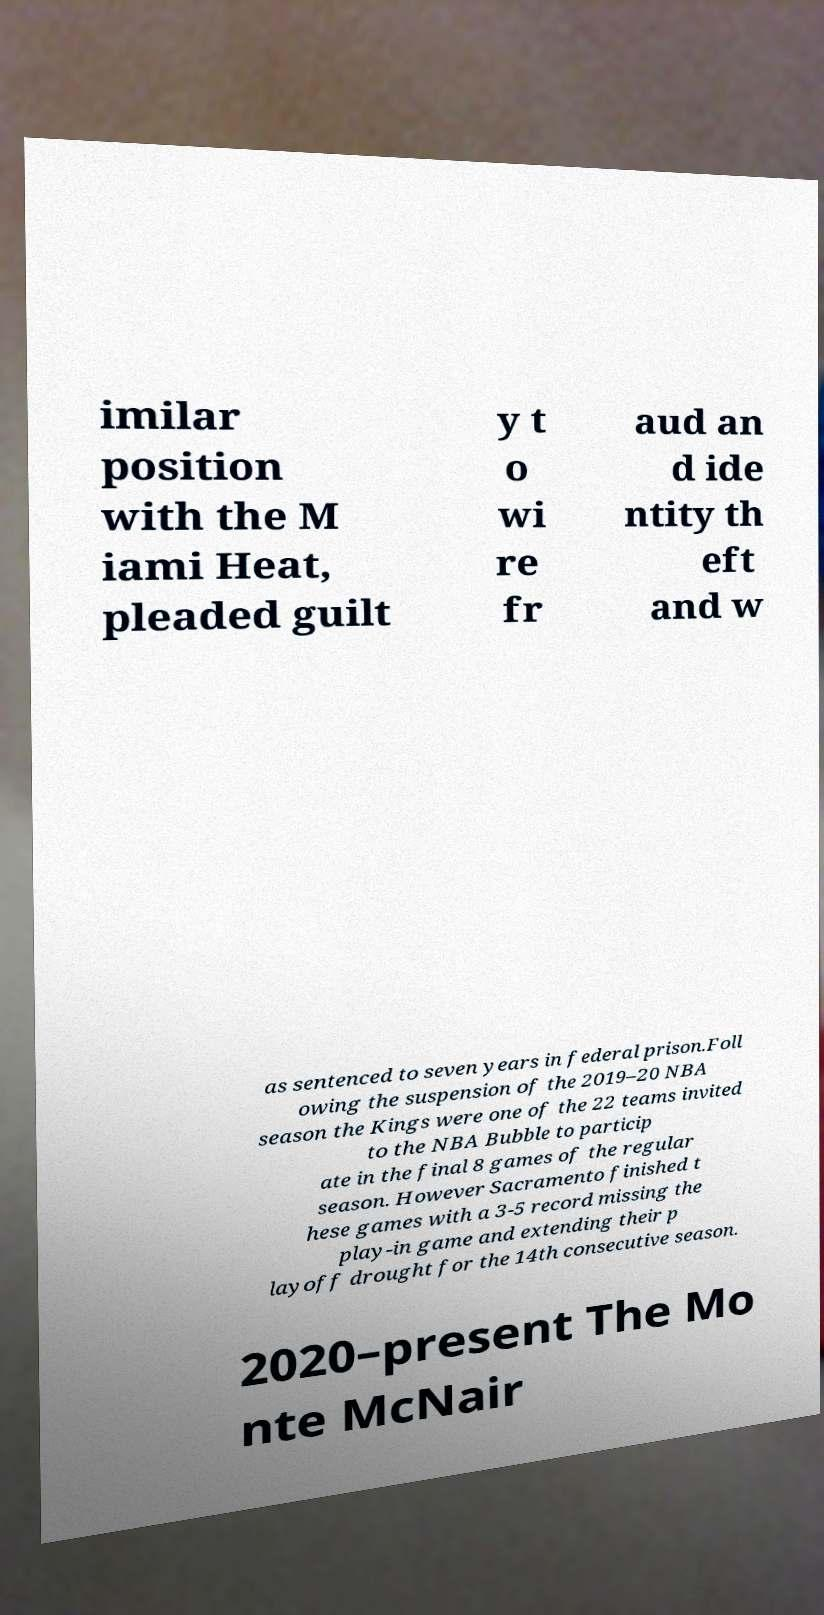Please read and relay the text visible in this image. What does it say? imilar position with the M iami Heat, pleaded guilt y t o wi re fr aud an d ide ntity th eft and w as sentenced to seven years in federal prison.Foll owing the suspension of the 2019–20 NBA season the Kings were one of the 22 teams invited to the NBA Bubble to particip ate in the final 8 games of the regular season. However Sacramento finished t hese games with a 3-5 record missing the play-in game and extending their p layoff drought for the 14th consecutive season. 2020–present The Mo nte McNair 